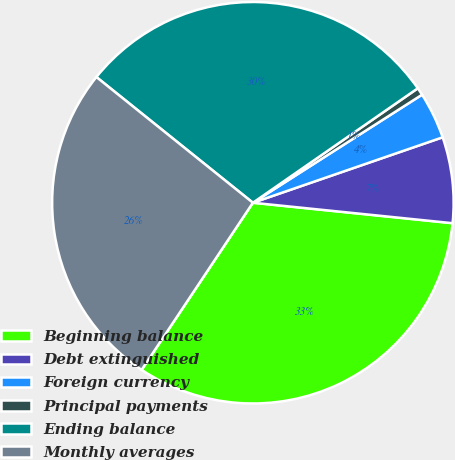Convert chart to OTSL. <chart><loc_0><loc_0><loc_500><loc_500><pie_chart><fcel>Beginning balance<fcel>Debt extinguished<fcel>Foreign currency<fcel>Principal payments<fcel>Ending balance<fcel>Monthly averages<nl><fcel>32.72%<fcel>6.91%<fcel>3.76%<fcel>0.61%<fcel>29.57%<fcel>26.42%<nl></chart> 